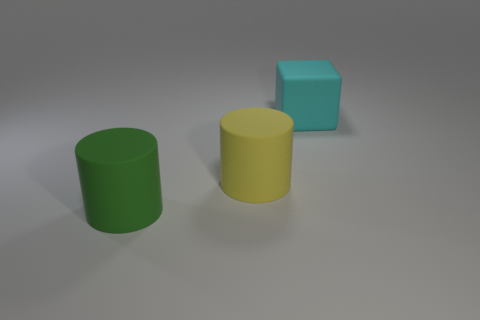Add 1 large green cylinders. How many objects exist? 4 Subtract all cylinders. How many objects are left? 1 Subtract all small gray rubber cylinders. Subtract all rubber cylinders. How many objects are left? 1 Add 1 large yellow objects. How many large yellow objects are left? 2 Add 1 green matte cylinders. How many green matte cylinders exist? 2 Subtract 0 red blocks. How many objects are left? 3 